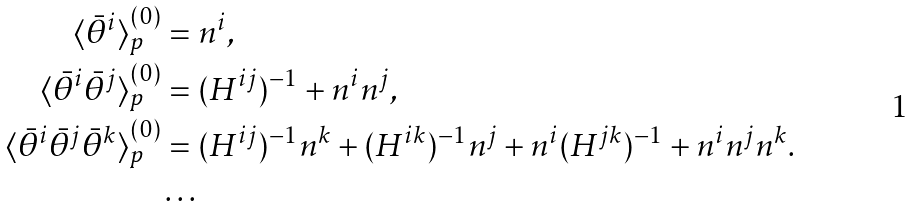<formula> <loc_0><loc_0><loc_500><loc_500>\langle \bar { \theta } ^ { i } \rangle ^ { ( 0 ) } _ { p } & = n ^ { i } , \\ \langle \bar { \theta } ^ { i } \bar { \theta } ^ { j } \rangle ^ { ( 0 ) } _ { p } & = ( H ^ { i j } ) ^ { - 1 } + n ^ { i } n ^ { j } , \\ \langle \bar { \theta } ^ { i } \bar { \theta } ^ { j } \bar { \theta } ^ { k } \rangle ^ { ( 0 ) } _ { p } & = ( H ^ { i j } ) ^ { - 1 } n ^ { k } + ( H ^ { i k } ) ^ { - 1 } n ^ { j } + n ^ { i } ( H ^ { j k } ) ^ { - 1 } + n ^ { i } n ^ { j } n ^ { k } . \\ & \dots</formula> 